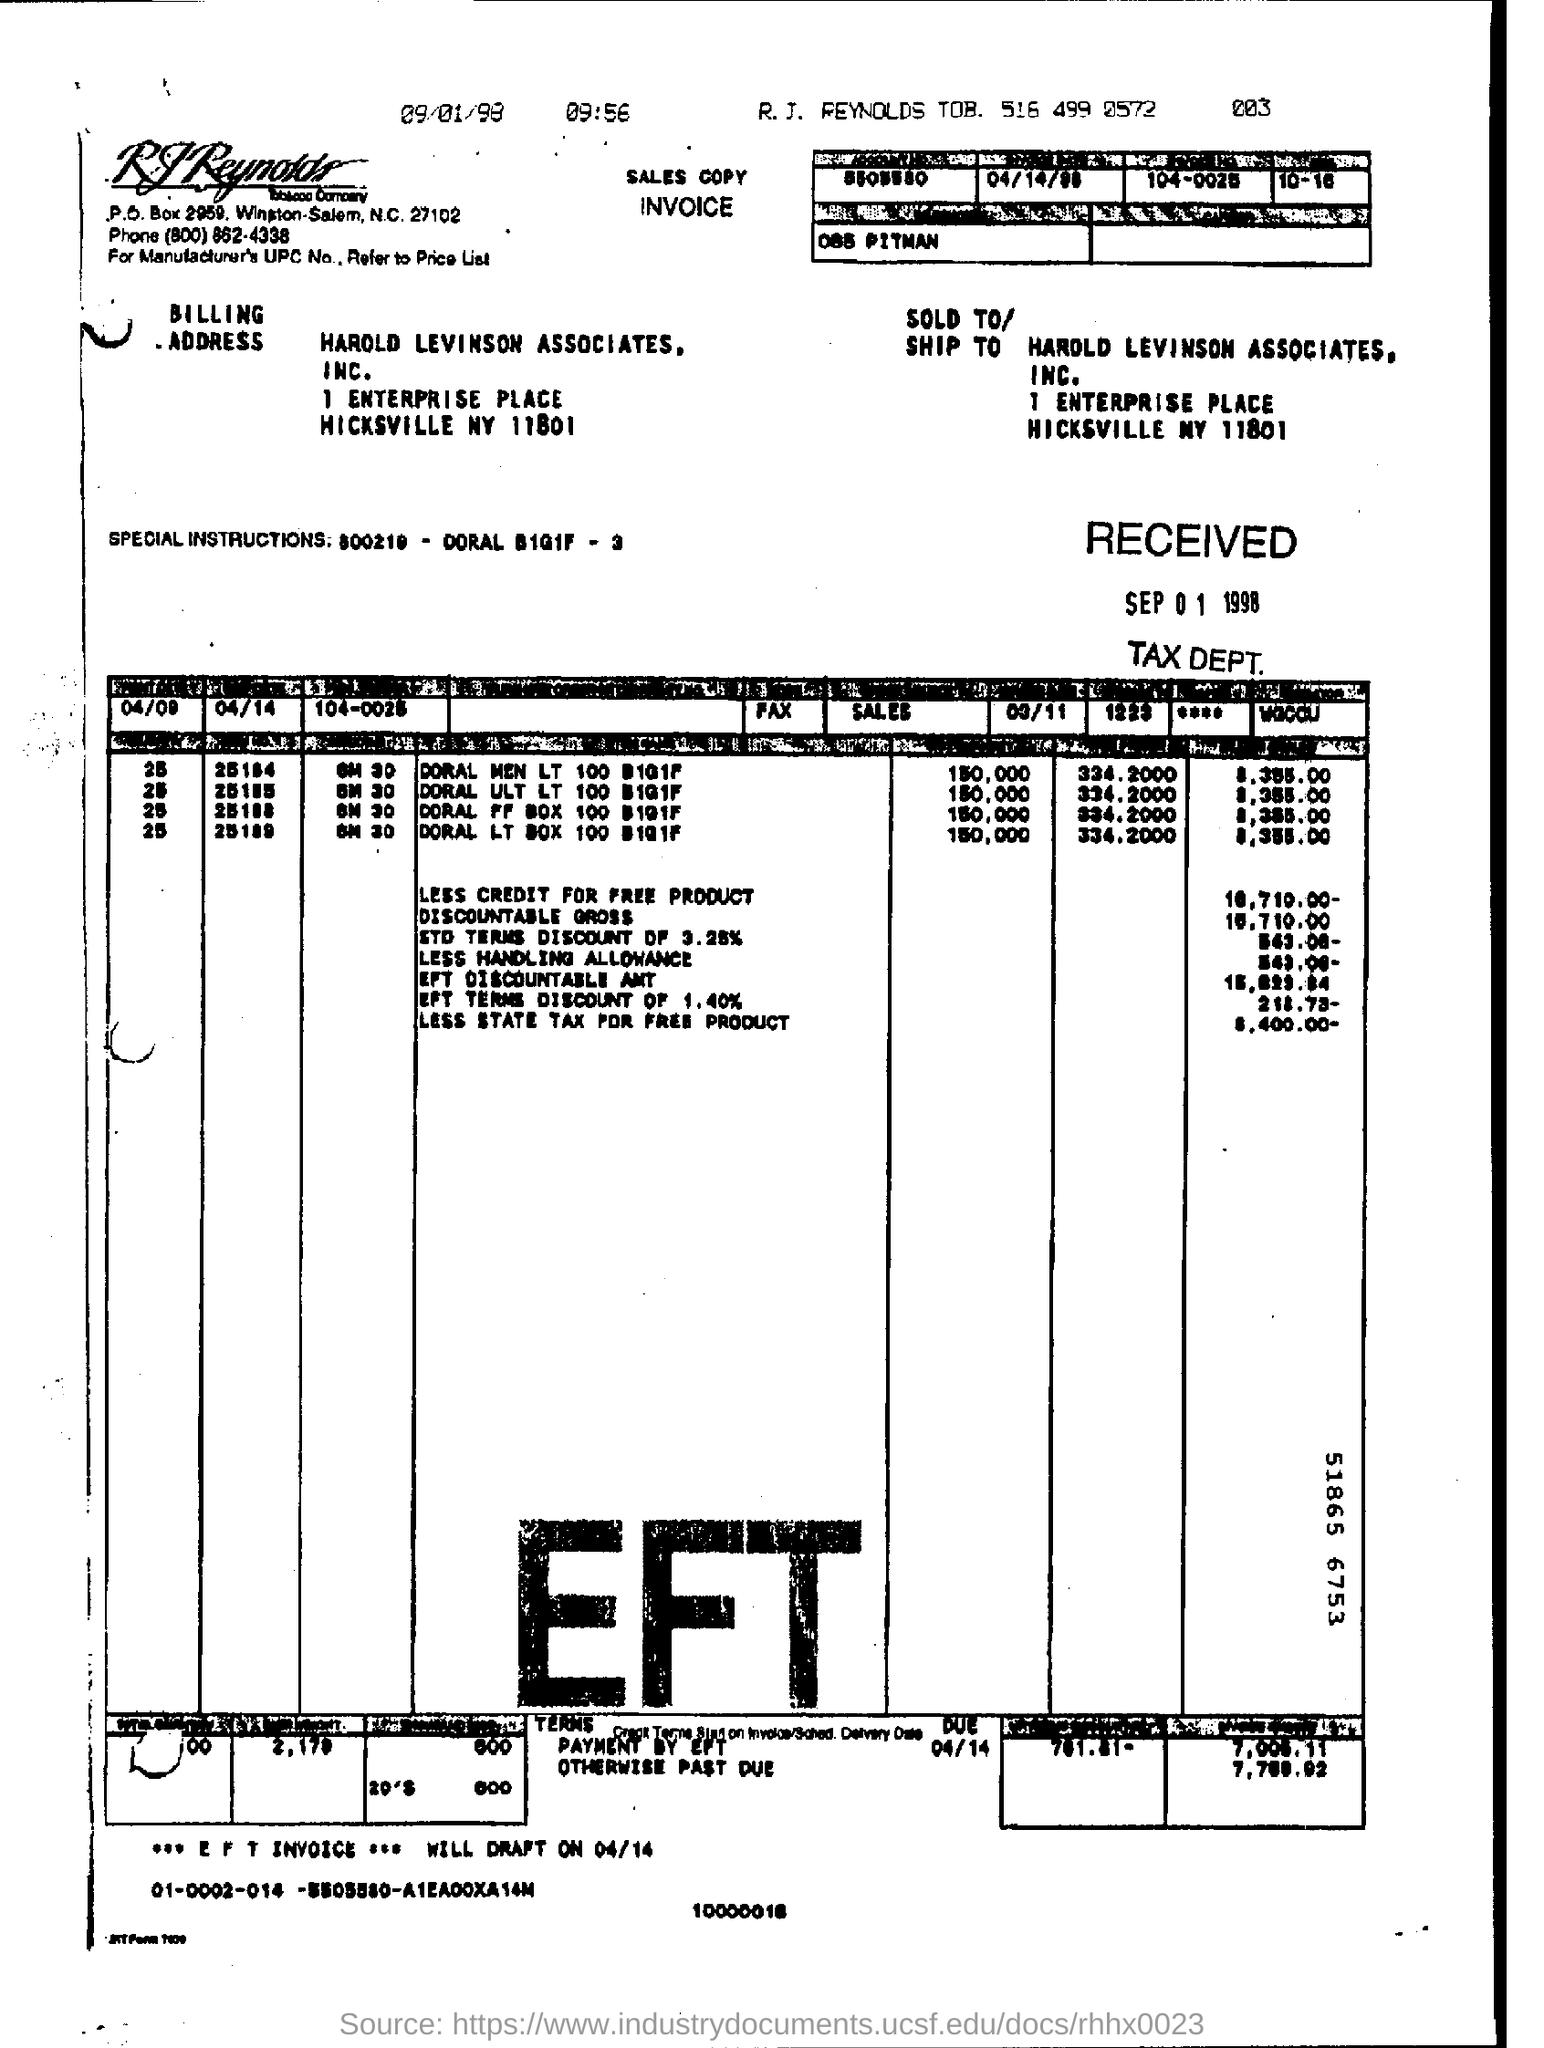Identify some key points in this picture. The zip code for the headquarters of RJ Reynolds Tobacco Company is 27102. 